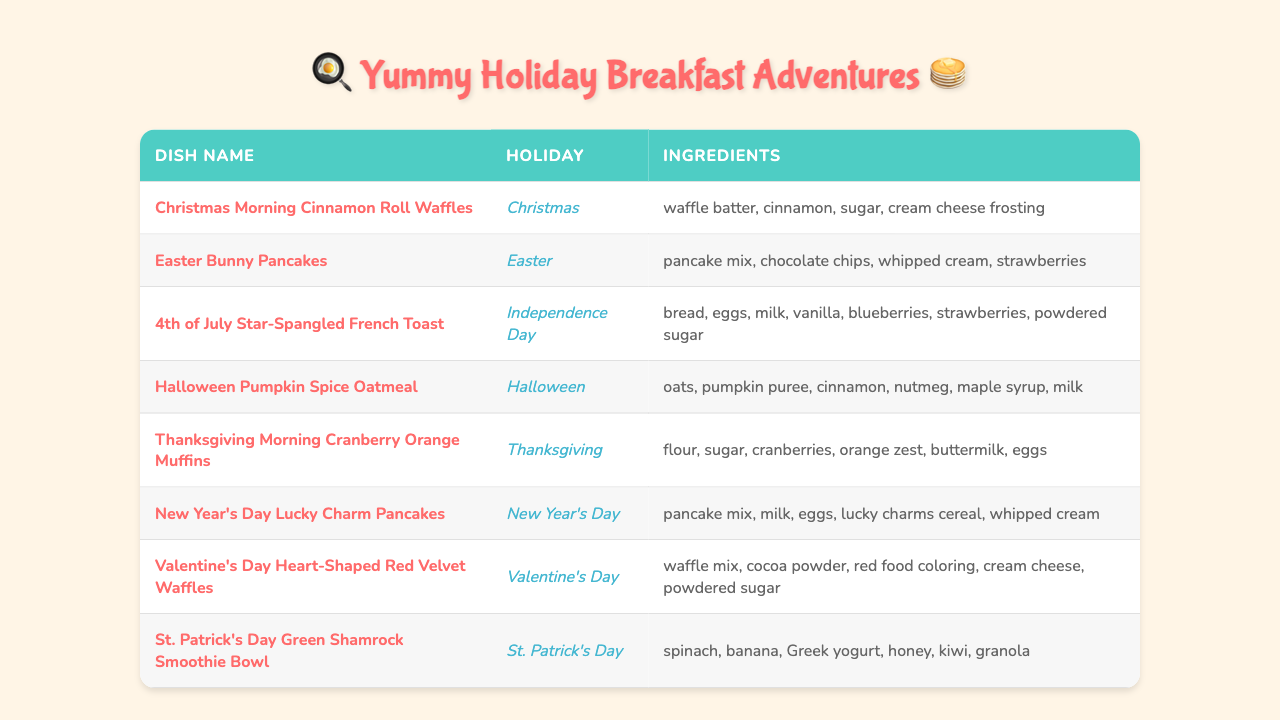What is the name of the dish served on Christmas? The table lists a special breakfast dish for Christmas which is "Christmas Morning Cinnamon Roll Waffles".
Answer: Christmas Morning Cinnamon Roll Waffles How many ingredients are in the Halloween Pumpkin Spice Oatmeal dish? Looking at the entry for Halloween Pumpkin Spice Oatmeal, it includes the ingredients: oats, pumpkin puree, cinnamon, nutmeg, maple syrup, and milk, totaling 6 ingredients.
Answer: 6 Is there a dish that includes strawberries among its ingredients? Checking the table, both "Easter Bunny Pancakes" and "4th of July Star-Spangled French Toast" have strawberries listed in their ingredients, confirming that there are dishes containing strawberries.
Answer: Yes Which holiday is associated with the dish that includes cream cheese frosting? The dish "Christmas Morning Cinnamon Roll Waffles" includes cream cheese frosting and is associated with the Christmas holiday.
Answer: Christmas What are the ingredients for New Year's Day Lucky Charm Pancakes? By referencing the New Year's Day Lucky Charm Pancakes entry, the ingredients listed are pancake mix, milk, eggs, lucky charms cereal, and whipped cream.
Answer: Pancake mix, milk, eggs, lucky charms cereal, whipped cream How many dishes do not use eggs as an ingredient? By examining the table, the dishes that do not list eggs in their ingredients are "Christmas Morning Cinnamon Roll Waffles," "Easter Bunny Pancakes," "Halloween Pumpkin Spice Oatmeal," and "St. Patrick's Day Green Shamrock Smoothie Bowl," making a total of 4 dishes without eggs.
Answer: 4 Which dish includes both blueberries and strawberries? The "4th of July Star-Spangled French Toast" is the only dish that mentions both blueberries and strawberries in its ingredients.
Answer: 4th of July Star-Spangled French Toast Does the Valentine's Day dish contain any dairy ingredients? The "Valentine's Day Heart-Shaped Red Velvet Waffles" includes cream cheese and powdered sugar, both of which can be dairy products, thus indicating that this dish does contain dairy.
Answer: Yes What is the total number of unique holidays represented in the table? The holidays listed in the table are Christmas, Easter, Independence Day, Halloween, Thanksgiving, New Year's Day, Valentine's Day, and St. Patrick's Day. Counting these, we find a total of 8 unique holidays.
Answer: 8 Which dish has the most ingredients listed? Analyzing the dishes, the "4th of July Star-Spangled French Toast" has 7 ingredients listed, which is the highest among all the dishes.
Answer: 4th of July Star-Spangled French Toast Is there a breakfast dish specifically for Thanksgiving? The "Thanksgiving Morning Cranberry Orange Muffins" is listed as a breakfast dish specifically for Thanksgiving.
Answer: Yes 